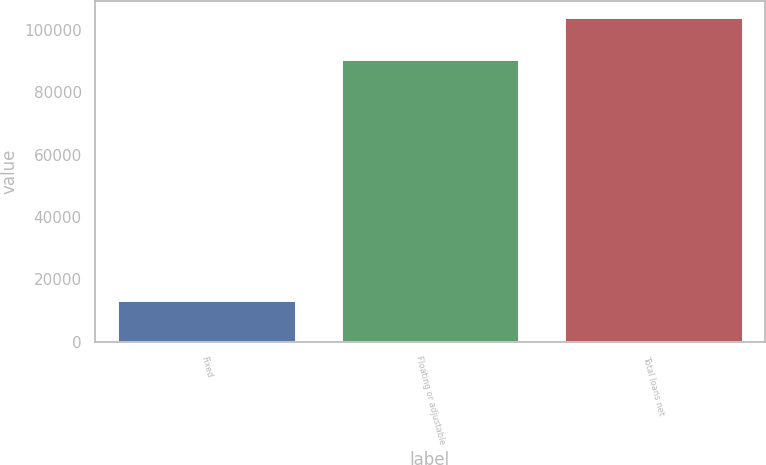<chart> <loc_0><loc_0><loc_500><loc_500><bar_chart><fcel>Fixed<fcel>Floating or adjustable<fcel>Total loans net<nl><fcel>13339<fcel>90787<fcel>104126<nl></chart> 